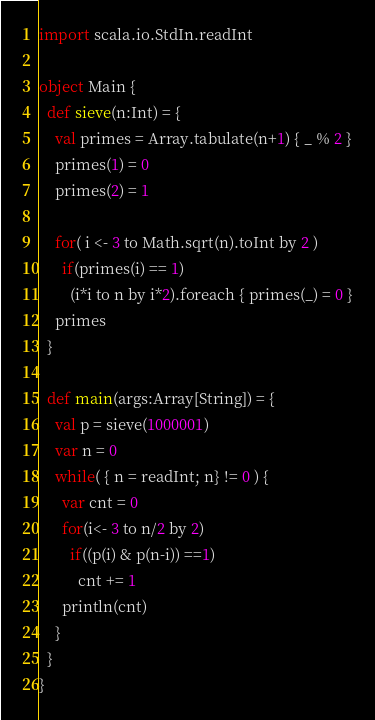<code> <loc_0><loc_0><loc_500><loc_500><_Scala_>import scala.io.StdIn.readInt

object Main {
  def sieve(n:Int) = {
    val primes = Array.tabulate(n+1) { _ % 2 }
    primes(1) = 0
    primes(2) = 1

    for( i <- 3 to Math.sqrt(n).toInt by 2 )
      if(primes(i) == 1)
        (i*i to n by i*2).foreach { primes(_) = 0 }
    primes
  }

  def main(args:Array[String]) = {
    val p = sieve(1000001)
    var n = 0
    while( { n = readInt; n} != 0 ) {
      var cnt = 0
      for(i<- 3 to n/2 by 2)
        if((p(i) & p(n-i)) ==1)
          cnt += 1
      println(cnt)
    }
  }
}</code> 